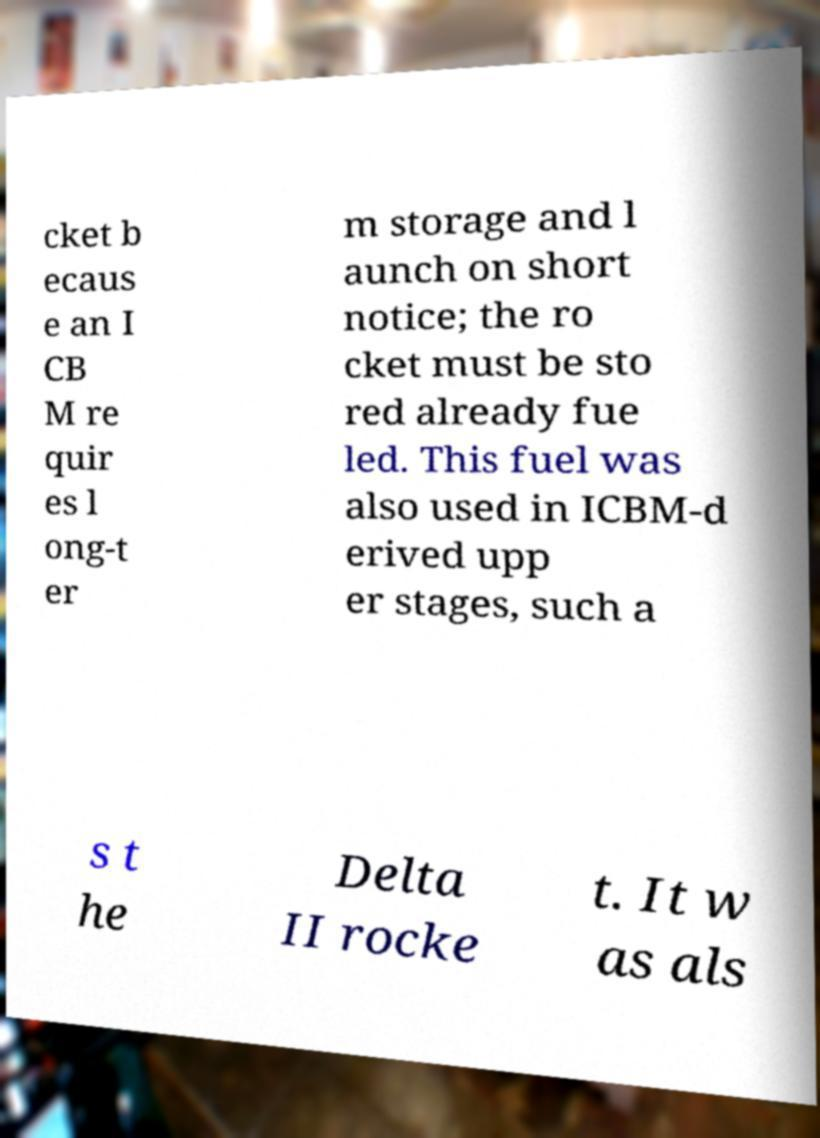Could you extract and type out the text from this image? cket b ecaus e an I CB M re quir es l ong-t er m storage and l aunch on short notice; the ro cket must be sto red already fue led. This fuel was also used in ICBM-d erived upp er stages, such a s t he Delta II rocke t. It w as als 